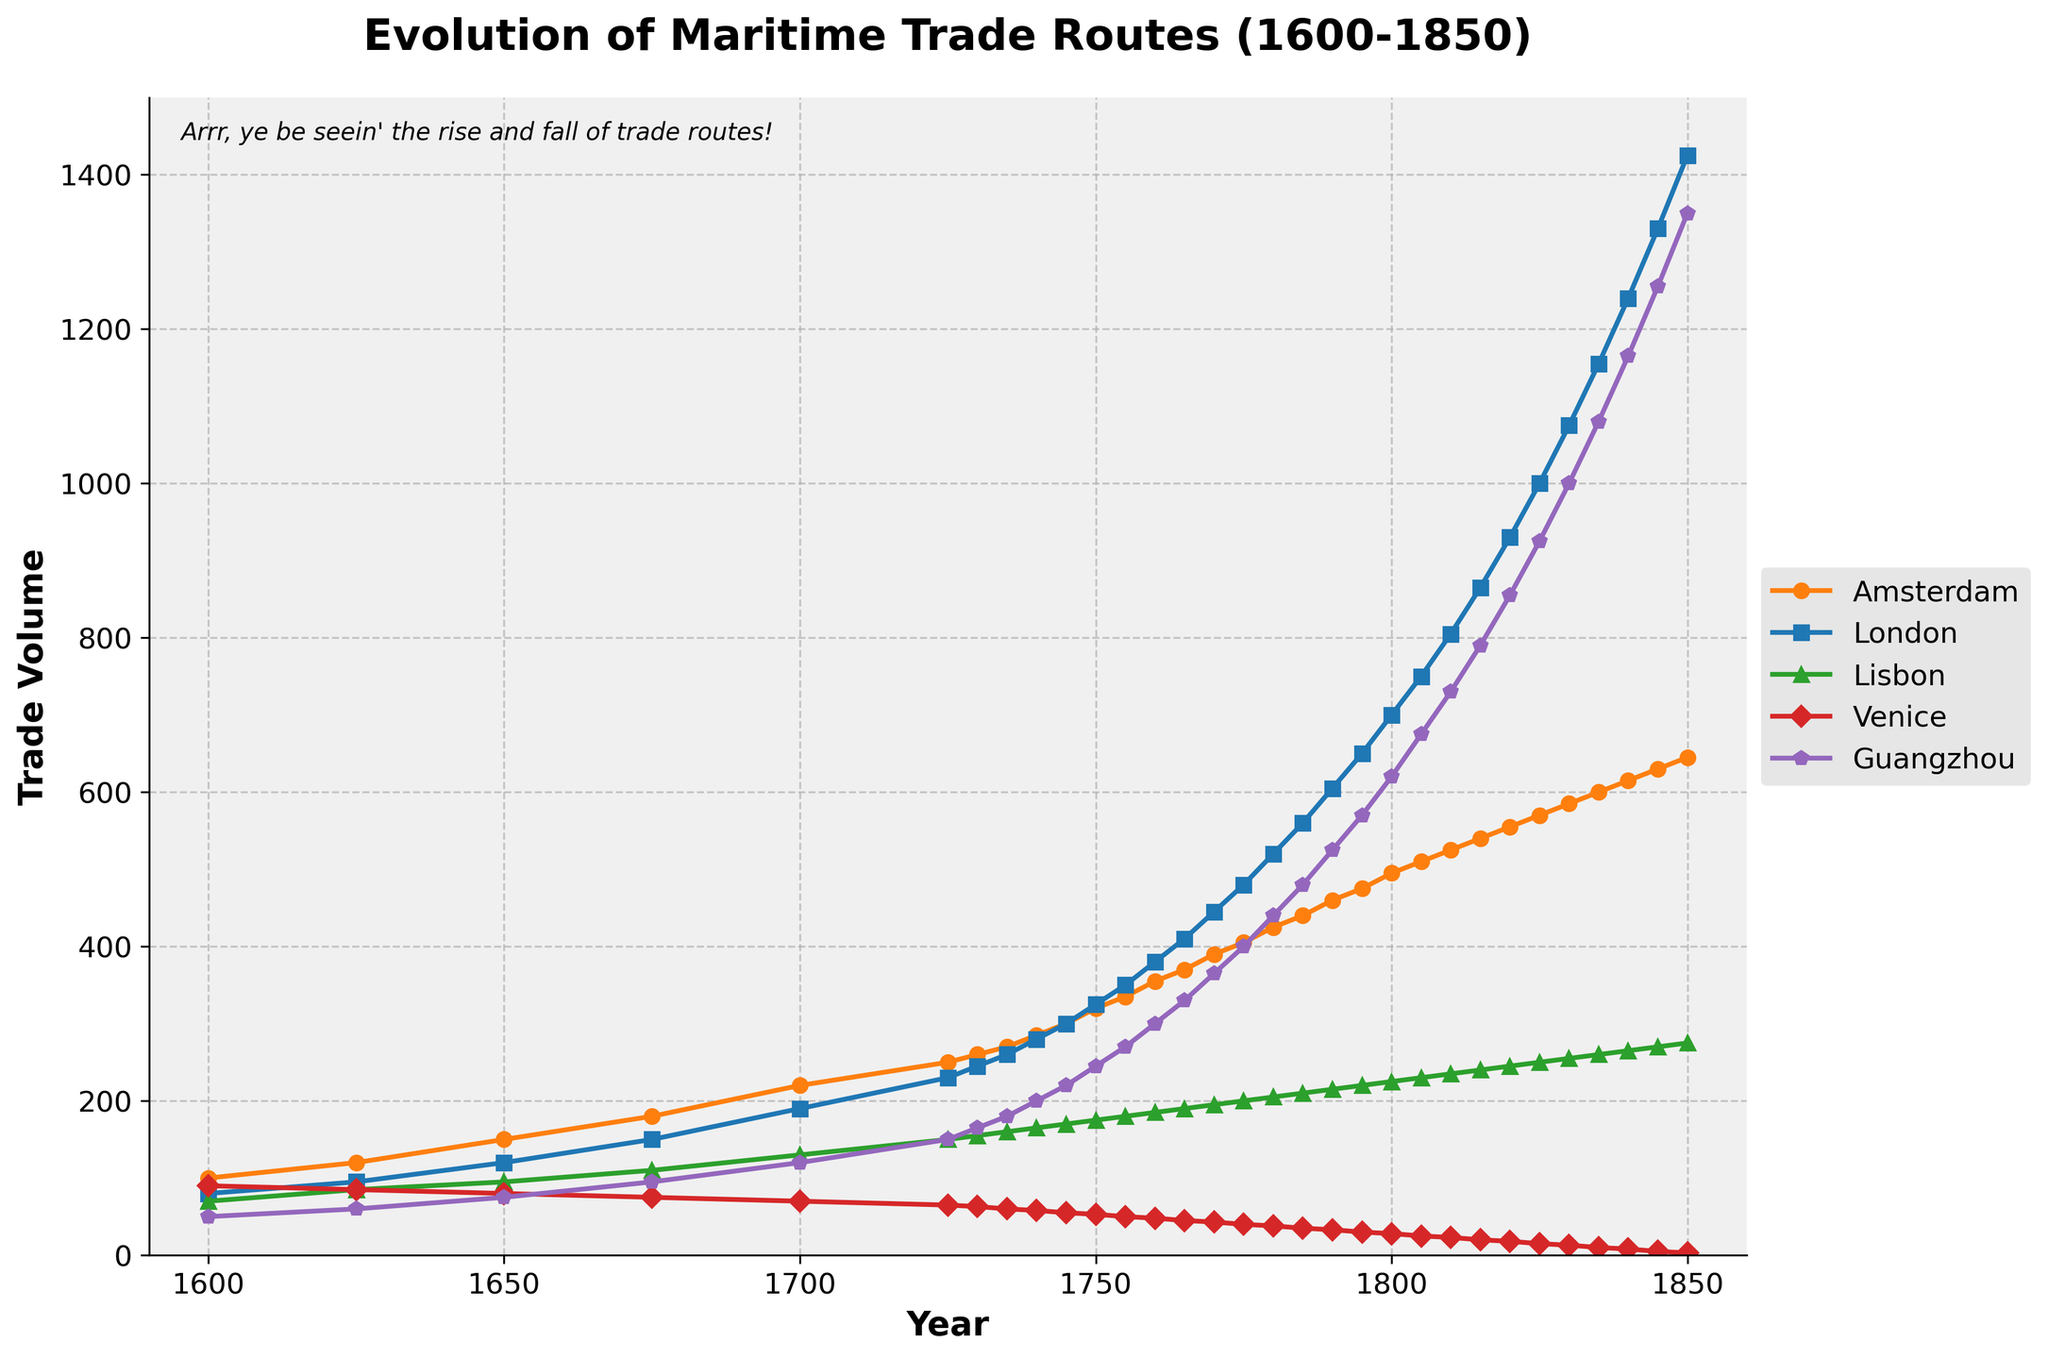What is the overall trend in the trade volume for Amsterdam from 1600 to 1850? The plot shows a steady increase in Amsterdam's trade volume from 1600 to 1850. At the beginning, the trade volume was 100 units, and it gradually increased to 645 units by 1850, indicating continuous growth over the years.
Answer: Continuous growth Which city had the highest trade volume in 1800, and what was that volume? On the plot, you can see that in 1800, London had the highest trade volume, which reached 700 units.
Answer: London, 700 units By how much did Guangzhou's trade volume increase from 1700 to 1850? Guangzhou's trade volume was 120 units in 1700 and increased to 1350 units by 1850. To find the increase: 1350 - 120 = 1230 units.
Answer: 1230 units Which city had the smallest increase in trade volume from 1600 to 1850? By examining the plot, Venice had the smallest increase in trade volume, starting from 90 units in 1600 and reaching only 3 units by 1850.
Answer: Venice What year did London surpass Amsterdam in trade volume? Looking at the plot, London surpassed Amsterdam in trade volume around 1735. Until then, Amsterdam's trade volume was higher or nearly equal to that of London.
Answer: Around 1735 How did Lisbon's trade volume change from 1775 to 1800? Lisbon's trade volume in 1775 was 200 units, and by 1800, it increased to 225 units. Therefore, the increase is 225 - 200 = 25 units.
Answer: Increase by 25 units What was the difference in trade volume between Amsterdam and Guangzhou in 1850? In 1850, Amsterdam's trade volume was 645 units, and Guangzhou's was 1350 units. The difference is 1350 - 645 = 705 units.
Answer: 705 units In which year did Guangzhou's trade volume first reach 300 units? The plot shows that Guangzhou's trade volume first reached 300 units in the year 1760.
Answer: 1760 Between which years did London see the highest increase in trade volume? Between 1805 and 1810, London experienced a significant increase in trade volume, from 750 to 805 units, which is a 55-unit increase in just five years.
Answer: 1805-1810 Which city's trade volume had the most rapid decline, and when did this occur? The plot indicates that Venice’s trade volume showed the most rapid decline, especially from 1775 (40 units) to 1850 (3 units).
Answer: Venice, 1775-1850 